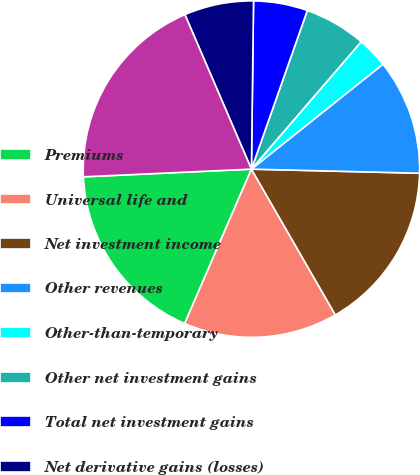Convert chart. <chart><loc_0><loc_0><loc_500><loc_500><pie_chart><fcel>Premiums<fcel>Universal life and<fcel>Net investment income<fcel>Other revenues<fcel>Other-than-temporary<fcel>Other net investment gains<fcel>Total net investment gains<fcel>Net derivative gains (losses)<fcel>Total revenues<nl><fcel>17.78%<fcel>14.81%<fcel>16.3%<fcel>11.11%<fcel>2.96%<fcel>5.93%<fcel>5.19%<fcel>6.67%<fcel>19.26%<nl></chart> 